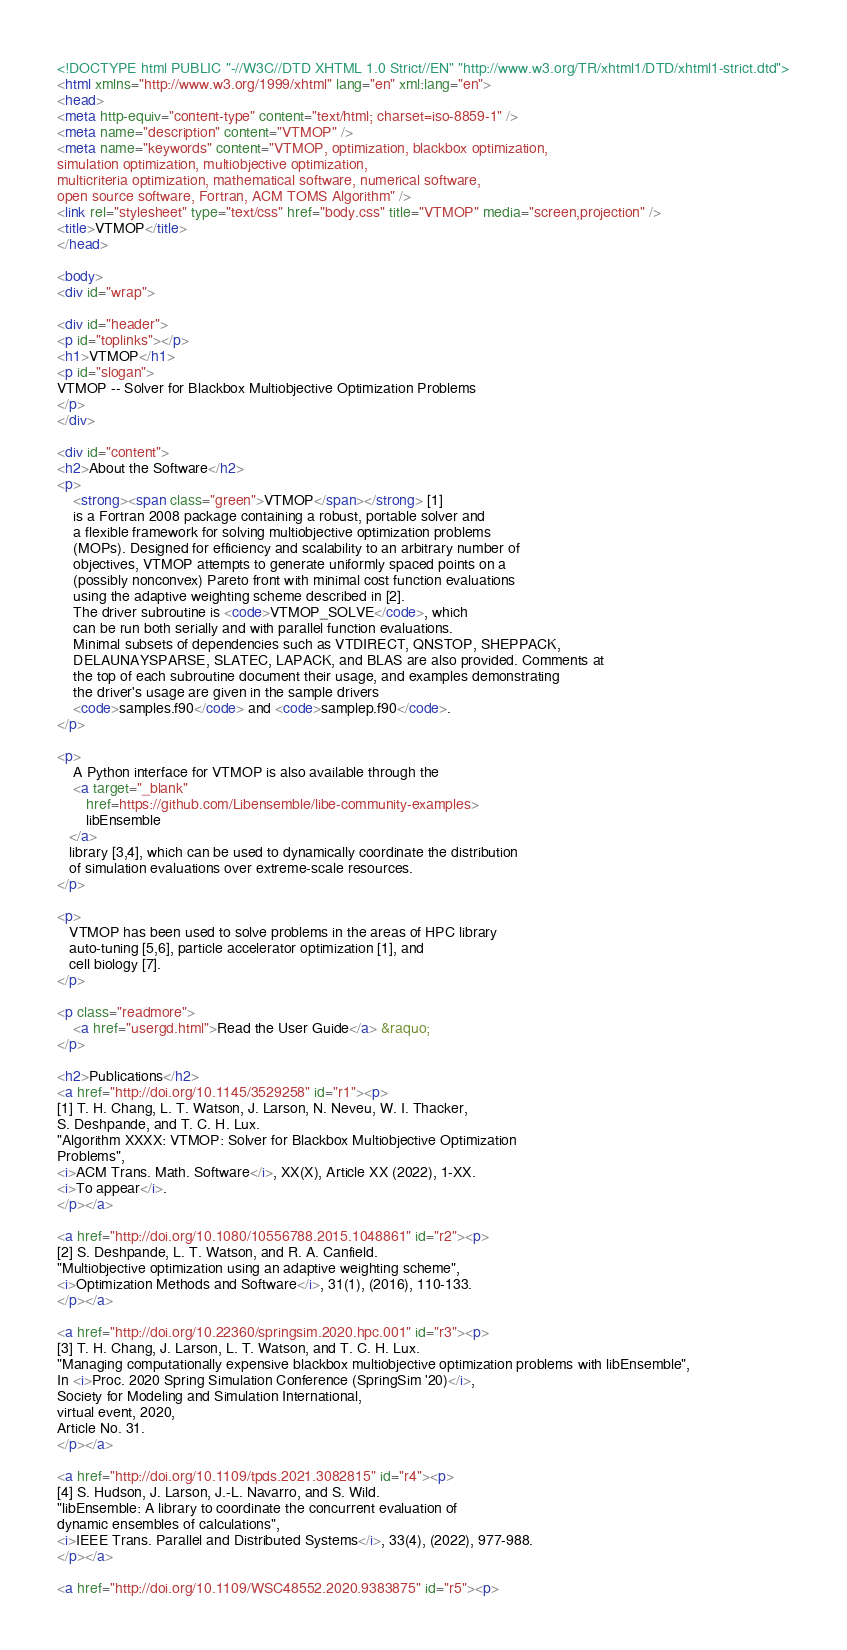<code> <loc_0><loc_0><loc_500><loc_500><_HTML_><!DOCTYPE html PUBLIC "-//W3C//DTD XHTML 1.0 Strict//EN" "http://www.w3.org/TR/xhtml1/DTD/xhtml1-strict.dtd">
<html xmlns="http://www.w3.org/1999/xhtml" lang="en" xml:lang="en">
<head>
<meta http-equiv="content-type" content="text/html; charset=iso-8859-1" />
<meta name="description" content="VTMOP" />
<meta name="keywords" content="VTMOP, optimization, blackbox optimization,
simulation optimization, multiobjective optimization,
multicriteria optimization, mathematical software, numerical software,
open source software, Fortran, ACM TOMS Algorithm" />
<link rel="stylesheet" type="text/css" href="body.css" title="VTMOP" media="screen,projection" />
<title>VTMOP</title>
</head>

<body>
<div id="wrap">

<div id="header">
<p id="toplinks"></p>
<h1>VTMOP</h1>
<p id="slogan">
VTMOP -- Solver for Blackbox Multiobjective Optimization Problems
</p>
</div>

<div id="content">
<h2>About the Software</h2>
<p>
    <strong><span class="green">VTMOP</span></strong> [1]
    is a Fortran 2008 package containing a robust, portable solver and
    a flexible framework for solving multiobjective optimization problems
    (MOPs). Designed for efficiency and scalability to an arbitrary number of
    objectives, VTMOP attempts to generate uniformly spaced points on a
    (possibly nonconvex) Pareto front with minimal cost function evaluations
    using the adaptive weighting scheme described in [2].
    The driver subroutine is <code>VTMOP_SOLVE</code>, which
    can be run both serially and with parallel function evaluations.
    Minimal subsets of dependencies such as VTDIRECT, QNSTOP, SHEPPACK,
    DELAUNAYSPARSE, SLATEC, LAPACK, and BLAS are also provided. Comments at
    the top of each subroutine document their usage, and examples demonstrating
    the driver's usage are given in the sample drivers
    <code>samples.f90</code> and <code>samplep.f90</code>.
</p>

<p>
    A Python interface for VTMOP is also available through the
    <a target="_blank"
       href=https://github.com/Libensemble/libe-community-examples>
       libEnsemble
   </a>
   library [3,4], which can be used to dynamically coordinate the distribution
   of simulation evaluations over extreme-scale resources.
</p>

<p>
   VTMOP has been used to solve problems in the areas of HPC library
   auto-tuning [5,6], particle accelerator optimization [1], and
   cell biology [7].
</p>

<p class="readmore">
    <a href="usergd.html">Read the User Guide</a> &raquo;
</p>

<h2>Publications</h2>
<a href="http://doi.org/10.1145/3529258" id="r1"><p>
[1] T. H. Chang, L. T. Watson, J. Larson, N. Neveu, W. I. Thacker,
S. Deshpande, and T. C. H. Lux.
"Algorithm XXXX: VTMOP: Solver for Blackbox Multiobjective Optimization
Problems",
<i>ACM Trans. Math. Software</i>, XX(X), Article XX (2022), 1-XX.
<i>To appear</i>.
</p></a>

<a href="http://doi.org/10.1080/10556788.2015.1048861" id="r2"><p>
[2] S. Deshpande, L. T. Watson, and R. A. Canfield.
"Multiobjective optimization using an adaptive weighting scheme",
<i>Optimization Methods and Software</i>, 31(1), (2016), 110-133.
</p></a>

<a href="http://doi.org/10.22360/springsim.2020.hpc.001" id="r3"><p>
[3] T. H. Chang, J. Larson, L. T. Watson, and T. C. H. Lux.
"Managing computationally expensive blackbox multiobjective optimization problems with libEnsemble",
In <i>Proc. 2020 Spring Simulation Conference (SpringSim '20)</i>,
Society for Modeling and Simulation International,
virtual event, 2020,
Article No. 31.
</p></a>

<a href="http://doi.org/10.1109/tpds.2021.3082815" id="r4"><p>
[4] S. Hudson, J. Larson, J.-L. Navarro, and S. Wild.
"libEnsemble: A library to coordinate the concurrent evaluation of
dynamic ensembles of calculations",
<i>IEEE Trans. Parallel and Distributed Systems</i>, 33(4), (2022), 977-988.
</p></a>

<a href="http://doi.org/10.1109/WSC48552.2020.9383875" id="r5"><p></code> 